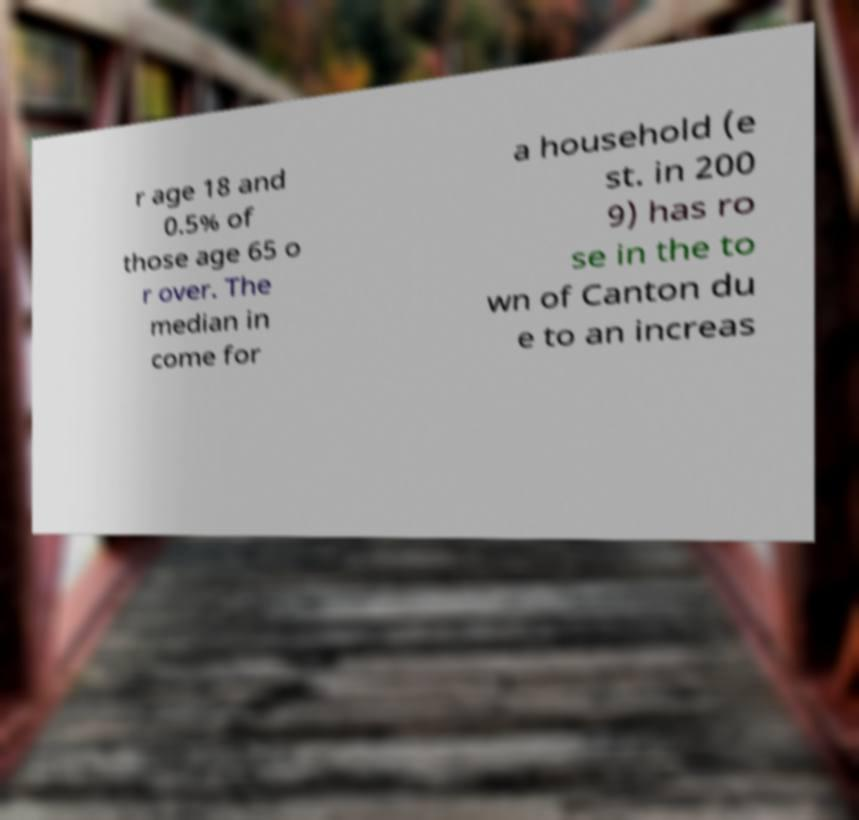Please read and relay the text visible in this image. What does it say? r age 18 and 0.5% of those age 65 o r over. The median in come for a household (e st. in 200 9) has ro se in the to wn of Canton du e to an increas 